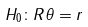<formula> <loc_0><loc_0><loc_500><loc_500>H _ { 0 } \colon R \theta = r</formula> 